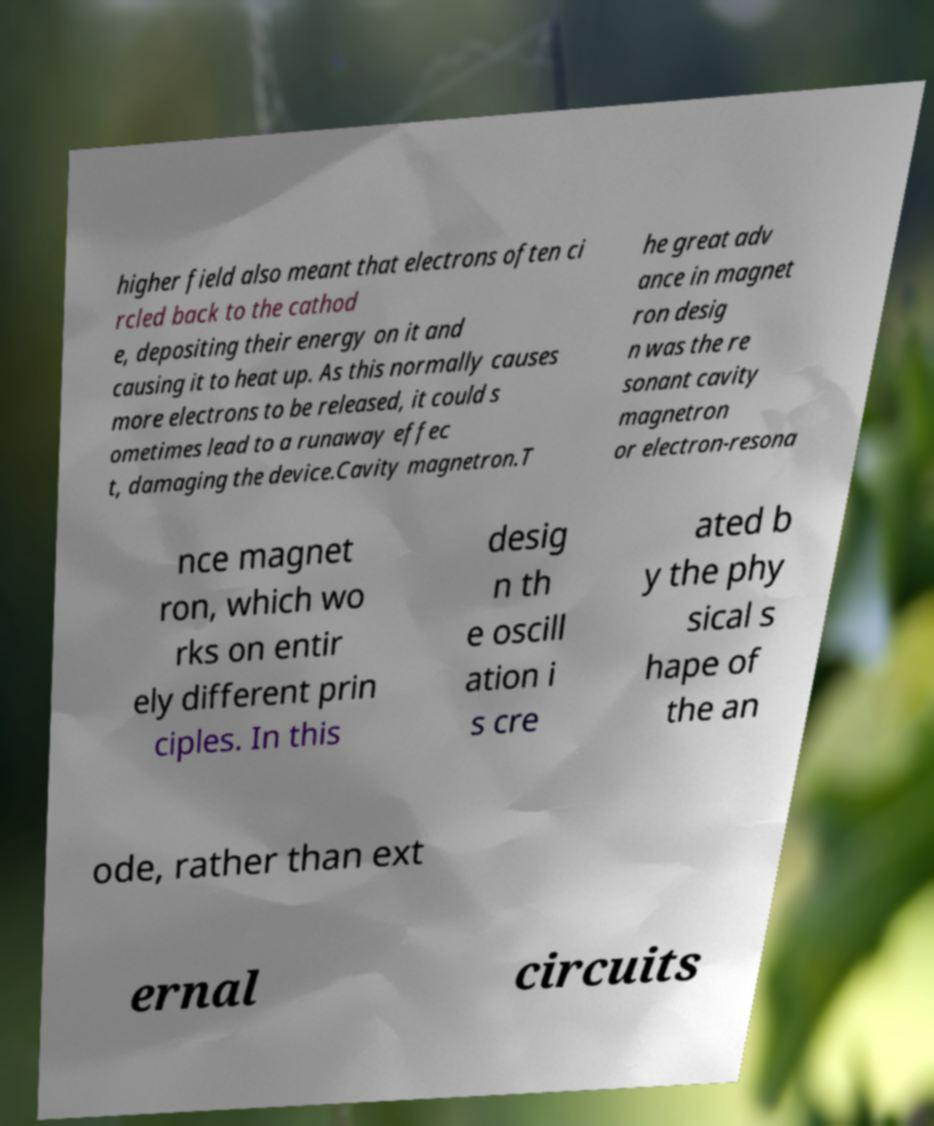Can you accurately transcribe the text from the provided image for me? higher field also meant that electrons often ci rcled back to the cathod e, depositing their energy on it and causing it to heat up. As this normally causes more electrons to be released, it could s ometimes lead to a runaway effec t, damaging the device.Cavity magnetron.T he great adv ance in magnet ron desig n was the re sonant cavity magnetron or electron-resona nce magnet ron, which wo rks on entir ely different prin ciples. In this desig n th e oscill ation i s cre ated b y the phy sical s hape of the an ode, rather than ext ernal circuits 